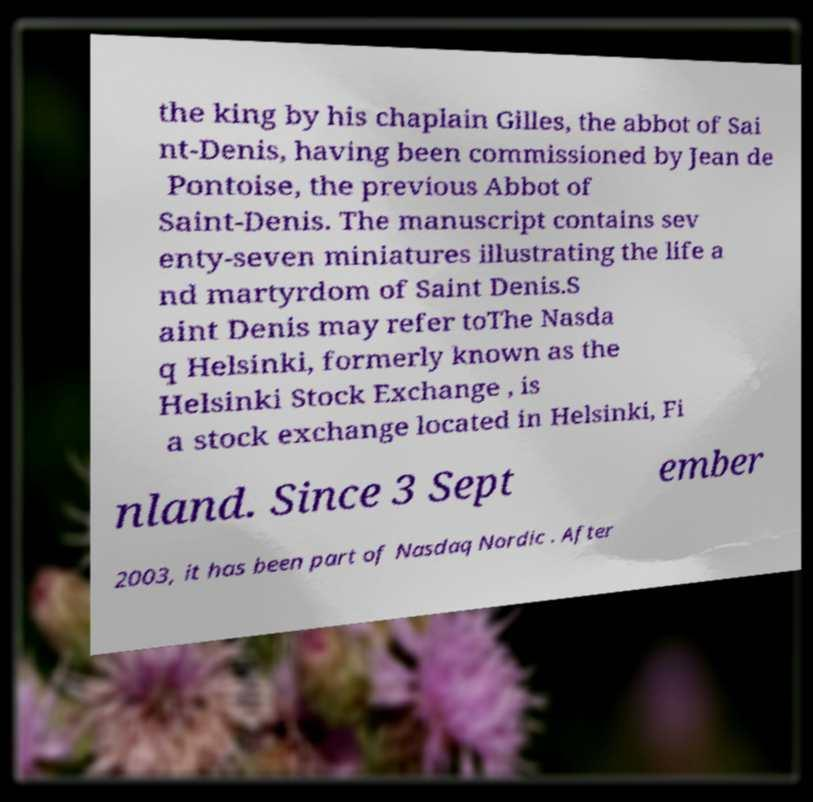Can you read and provide the text displayed in the image?This photo seems to have some interesting text. Can you extract and type it out for me? the king by his chaplain Gilles, the abbot of Sai nt-Denis, having been commissioned by Jean de Pontoise, the previous Abbot of Saint-Denis. The manuscript contains sev enty-seven miniatures illustrating the life a nd martyrdom of Saint Denis.S aint Denis may refer toThe Nasda q Helsinki, formerly known as the Helsinki Stock Exchange , is a stock exchange located in Helsinki, Fi nland. Since 3 Sept ember 2003, it has been part of Nasdaq Nordic . After 